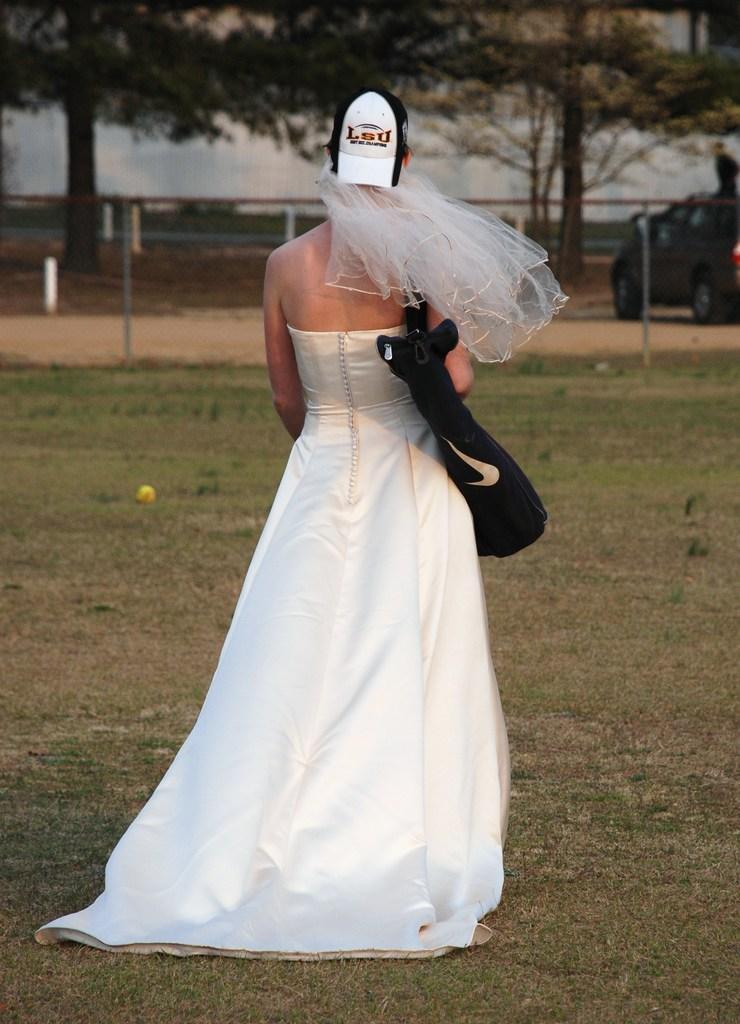Could you give a brief overview of what you see in this image? In this image there is a person wearing the hat and a bag. At the bottom of the image there is grass on the surface. In the center of the image there is a metal fence. There is a car. In the background of the image there are trees and there is a wall. 